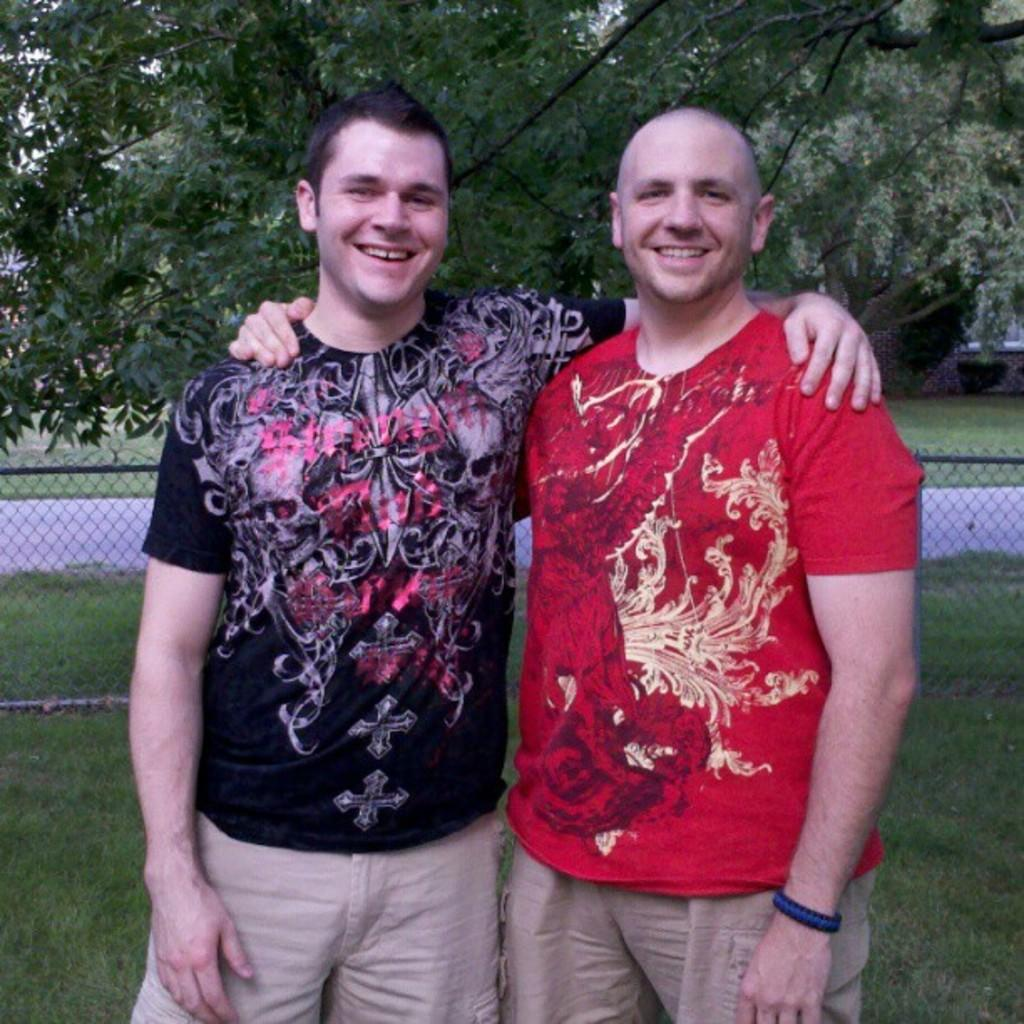How many men are in the foreground of the picture? There are two men standing in the foreground of the picture. What expression do the men have in the image? The men are smiling in the image. What type of terrain is visible in the image? There is grass visible in the image. What architectural feature can be seen in the image? There is a railing in the image. What can be seen in the background of the image? There are trees and a path visible in the background of the image. What is the weight of the stamp on the boot in the image? There is no stamp or boot present in the image. 